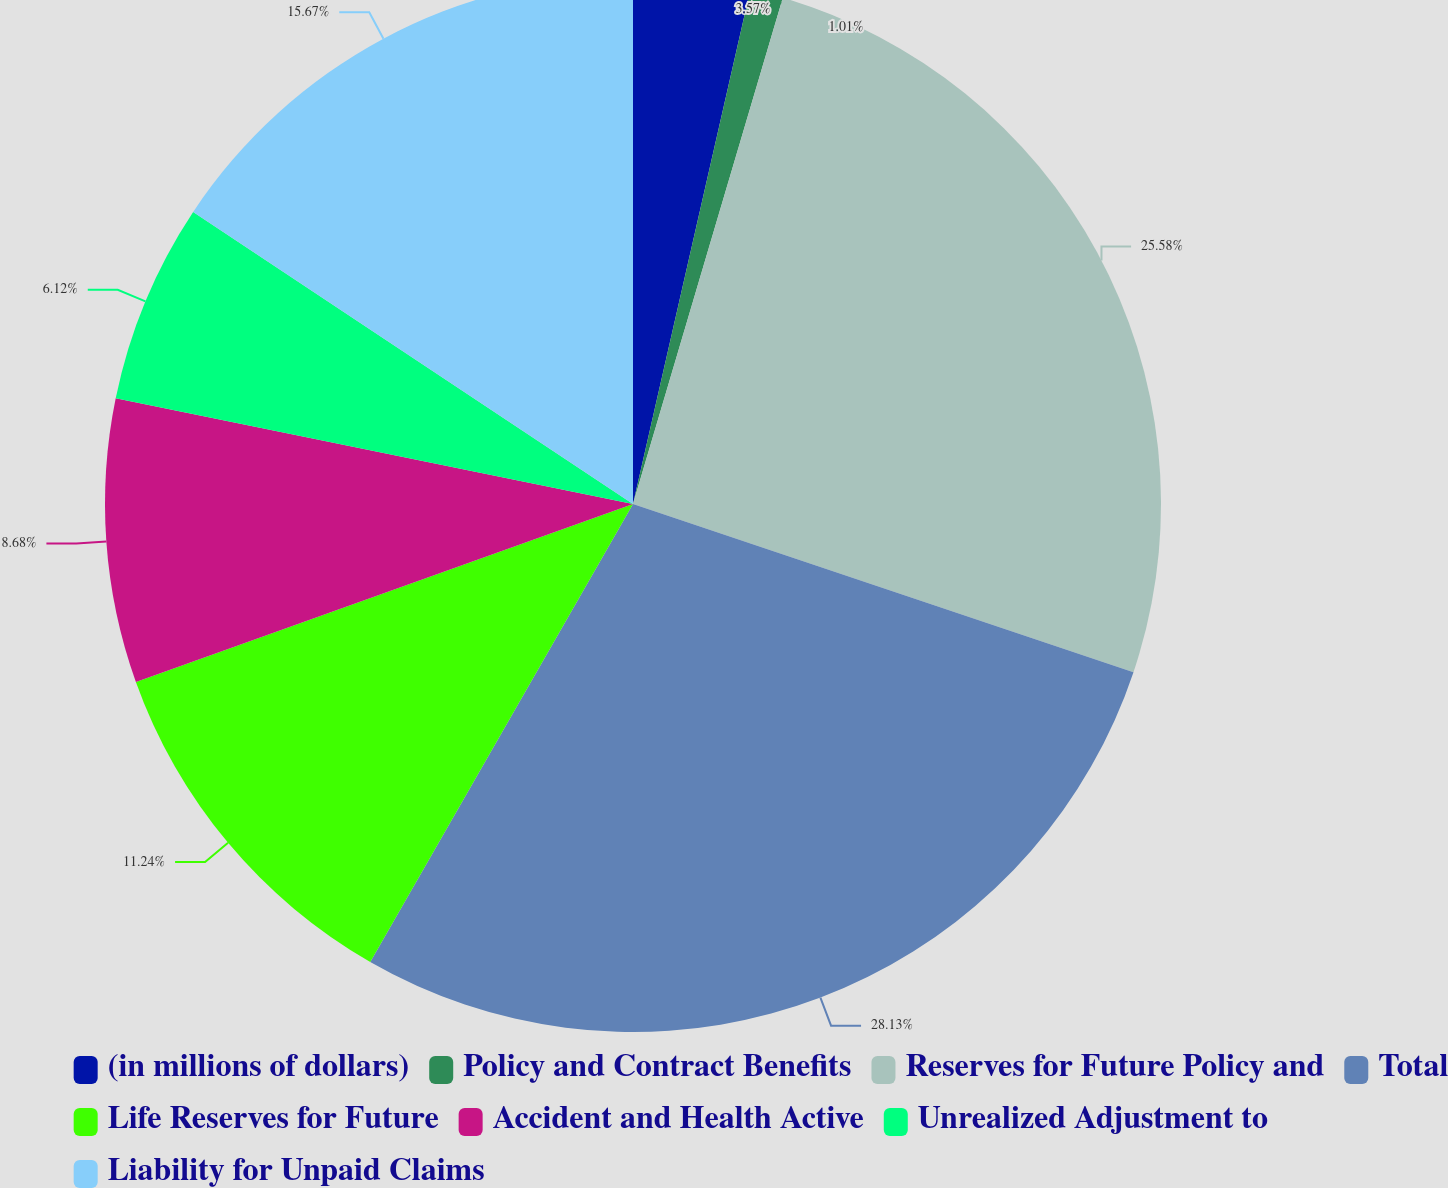Convert chart. <chart><loc_0><loc_0><loc_500><loc_500><pie_chart><fcel>(in millions of dollars)<fcel>Policy and Contract Benefits<fcel>Reserves for Future Policy and<fcel>Total<fcel>Life Reserves for Future<fcel>Accident and Health Active<fcel>Unrealized Adjustment to<fcel>Liability for Unpaid Claims<nl><fcel>3.57%<fcel>1.01%<fcel>25.58%<fcel>28.13%<fcel>11.24%<fcel>8.68%<fcel>6.12%<fcel>15.67%<nl></chart> 